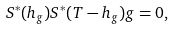Convert formula to latex. <formula><loc_0><loc_0><loc_500><loc_500>S ^ { * } ( h _ { g } ) S ^ { * } ( T - h _ { g } ) g = 0 ,</formula> 